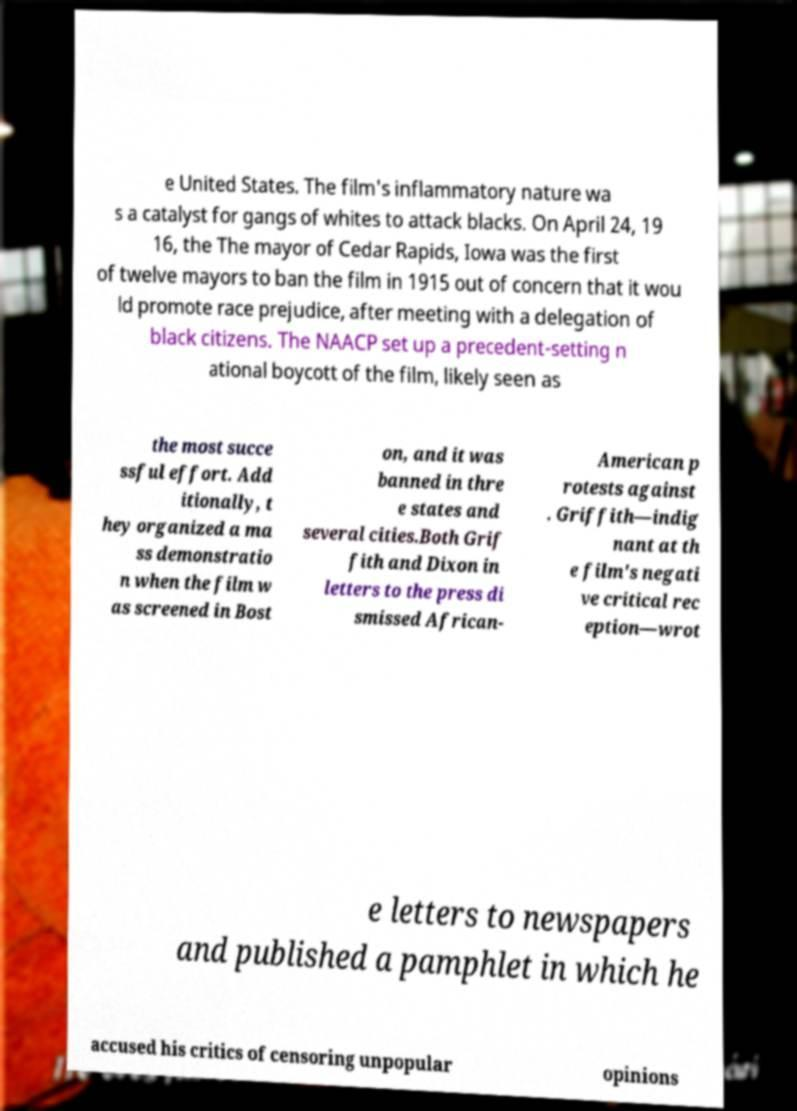Can you accurately transcribe the text from the provided image for me? e United States. The film's inflammatory nature wa s a catalyst for gangs of whites to attack blacks. On April 24, 19 16, the The mayor of Cedar Rapids, Iowa was the first of twelve mayors to ban the film in 1915 out of concern that it wou ld promote race prejudice, after meeting with a delegation of black citizens. The NAACP set up a precedent-setting n ational boycott of the film, likely seen as the most succe ssful effort. Add itionally, t hey organized a ma ss demonstratio n when the film w as screened in Bost on, and it was banned in thre e states and several cities.Both Grif fith and Dixon in letters to the press di smissed African- American p rotests against . Griffith—indig nant at th e film's negati ve critical rec eption—wrot e letters to newspapers and published a pamphlet in which he accused his critics of censoring unpopular opinions 